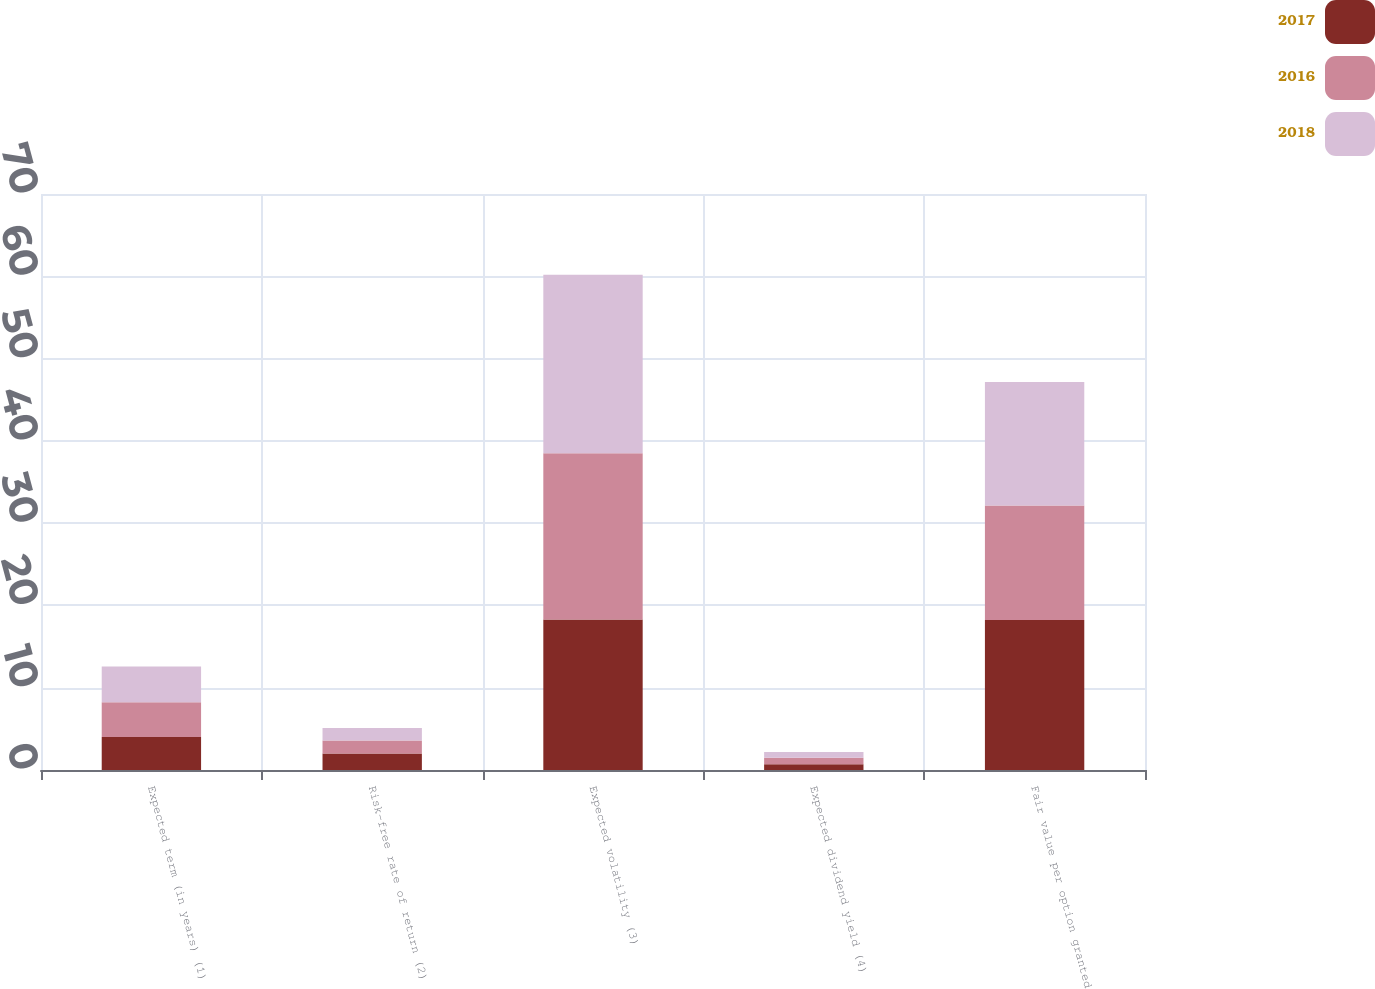<chart> <loc_0><loc_0><loc_500><loc_500><stacked_bar_chart><ecel><fcel>Expected term (in years) (1)<fcel>Risk-free rate of return (2)<fcel>Expected volatility (3)<fcel>Expected dividend yield (4)<fcel>Fair value per option granted<nl><fcel>2017<fcel>4<fcel>2<fcel>18.3<fcel>0.7<fcel>18.24<nl><fcel>2016<fcel>4.23<fcel>1.6<fcel>20.2<fcel>0.8<fcel>13.9<nl><fcel>2018<fcel>4.35<fcel>1.5<fcel>21.7<fcel>0.7<fcel>15.01<nl></chart> 